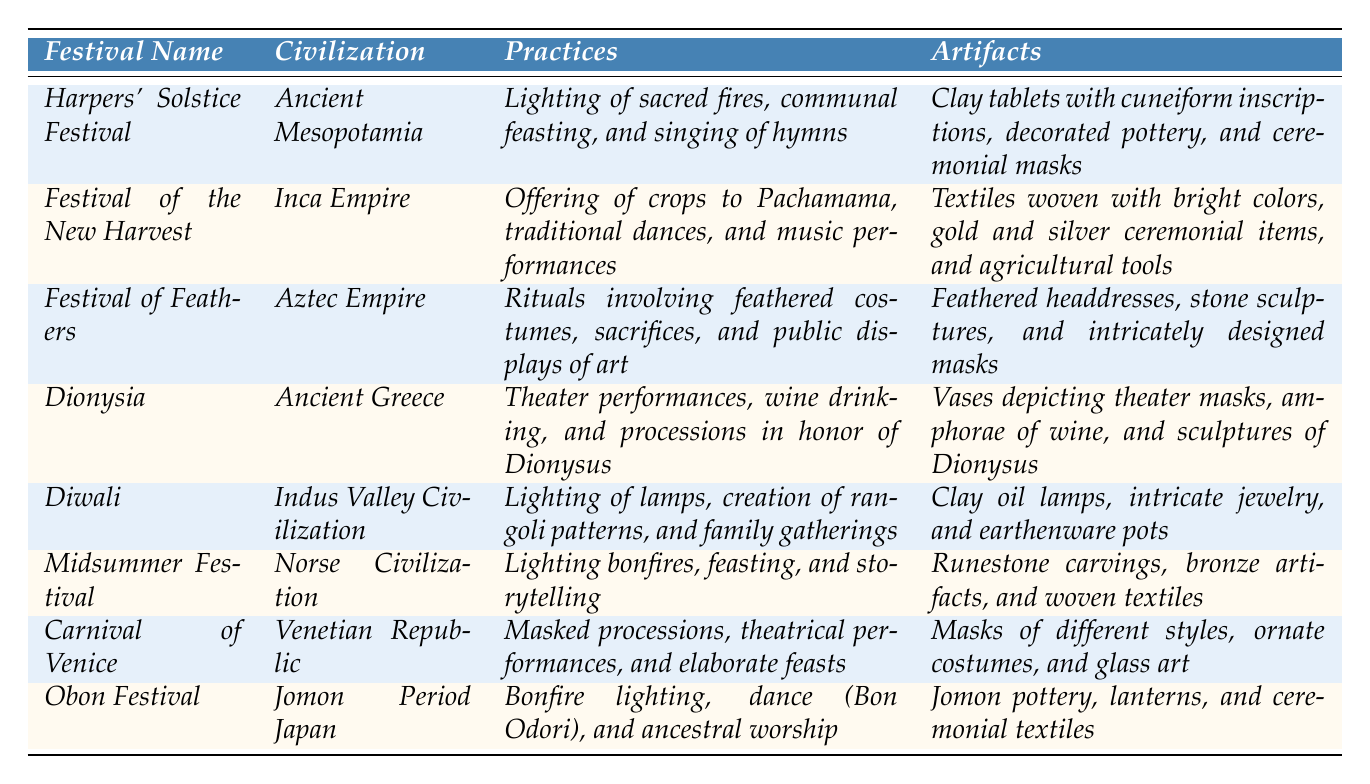What is the festival associated with the Inca Empire? The table lists various festivals, and for the Inca Empire, the festival is named "Festival of the New Harvest."
Answer: Festival of the New Harvest Which civilization celebrates the Harpers' Solstice Festival? According to the table, the Harpers' Solstice Festival is celebrated by the Ancient Mesopotamia civilization.
Answer: Ancient Mesopotamia How many artifacts are listed for the Carnival of Venice? The table indicates that the Carnival of Venice has three artifacts: masks of different styles, ornate costumes, and glass art. Therefore, the count is 3.
Answer: 3 Do the practices of the Diwali festival include ancestral worship? Reviewing the table, it is clear that the practices of Diwali do not include ancestral worship; instead, they focus on lighting lamps, creating rangoli, and family gatherings.
Answer: No What are the main practices for the Festival of Feathers? The table lists the main practices for the Festival of Feathers as: rituals involving feathered costumes, sacrifices, and public displays of art.
Answer: Rituals involving feathered costumes, sacrifices, and public displays of art Can you name three artifacts associated with the Dionysia festival? The table shows that the artifacts for the Dionysia festival include vases depicting theater masks, amphorae of wine, and sculptures of Dionysus. Thus, the three artifacts can be named directly from this list.
Answer: Vases depicting theater masks, amphorae of wine, and sculptures of Dionysus Which festival involves the lighting of bonfires as part of its practices? The table indicates that the Midsummer Festival is associated with lighting bonfires, feasting, and storytelling.
Answer: Midsummer Festival How many civilizations have festivals that involve dance? From the table, the following civilizations are involved with dance during festivals: Inca Empire (Festival of the New Harvest), Aztec Empire (Festival of Feathers), and Jomon Period Japan (Obon Festival). Hence, there are three civilizations.
Answer: 3 Is the Obon Festival associated with lighting of sacred fires? The table specifies that the practices of the Obon Festival include bonfire lighting, dance, and ancestral worship, but does not mention sacred fires, which are associated with the Harpers' Solstice Festival instead.
Answer: No What are the elements of communal feasting found in the Harpers' Solstice Festival? According to the table, the communal feasting at the Harpers' Solstice Festival includes lighting sacred fires and singing hymns as parts of the overall celebration.
Answer: Lighting of sacred fires and singing of hymns Which festival from the table is characterized by masked processions? Looking at the table, the Carnival of Venice clearly features masked processions as one of its main practices.
Answer: Carnival of Venice 